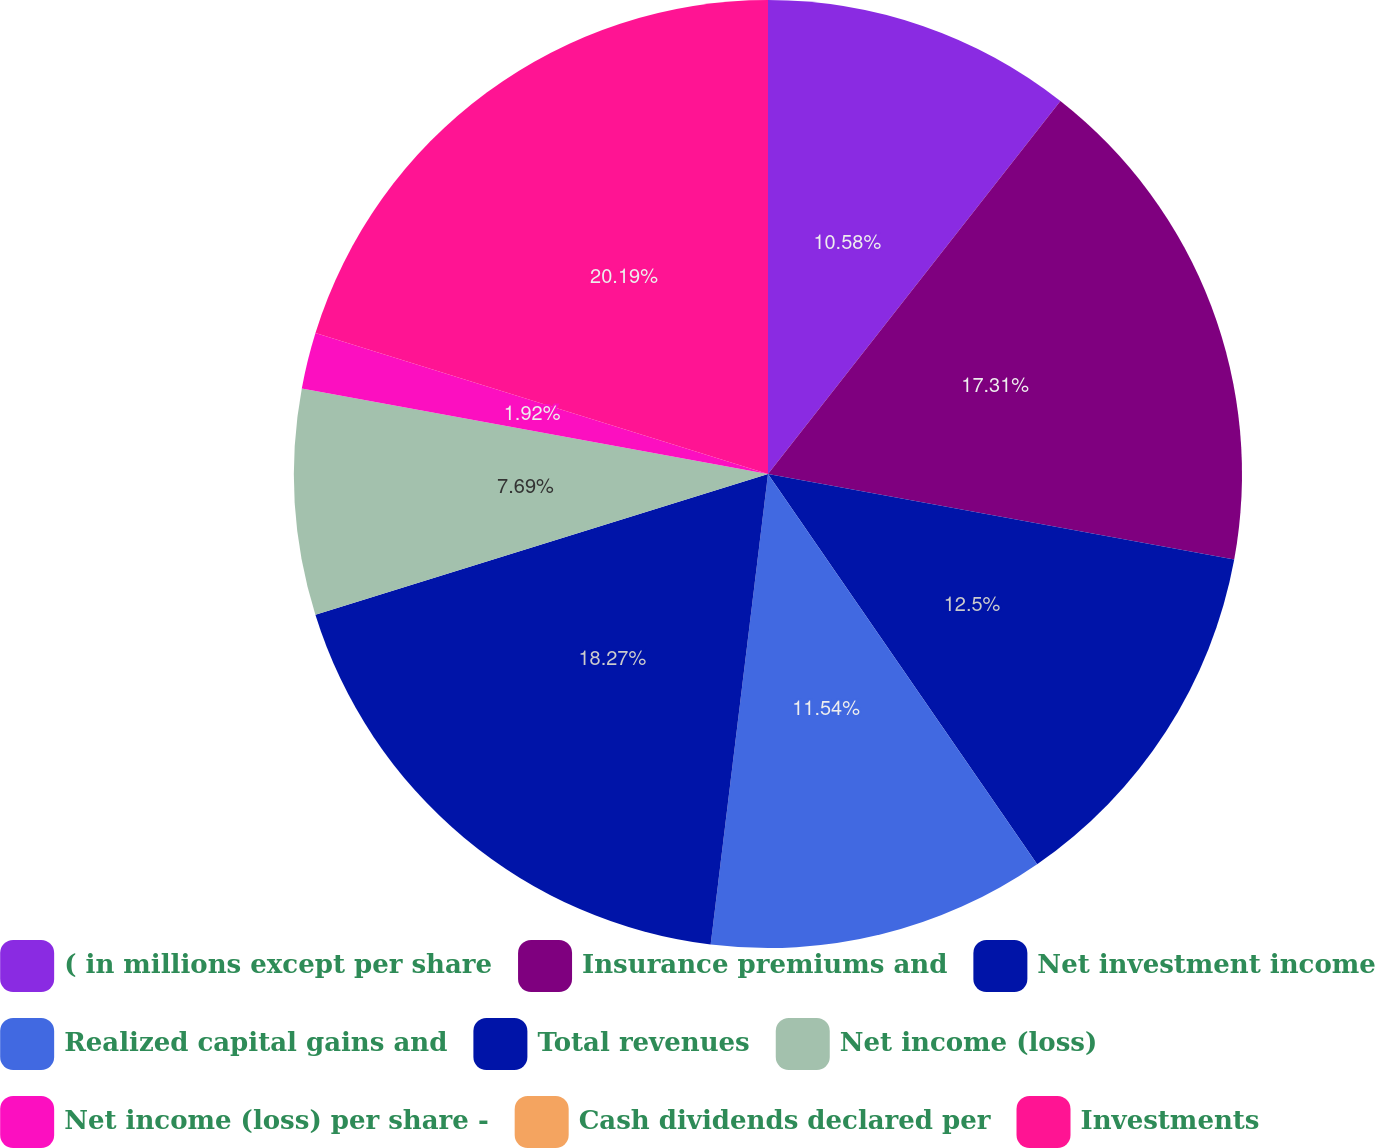Convert chart. <chart><loc_0><loc_0><loc_500><loc_500><pie_chart><fcel>( in millions except per share<fcel>Insurance premiums and<fcel>Net investment income<fcel>Realized capital gains and<fcel>Total revenues<fcel>Net income (loss)<fcel>Net income (loss) per share -<fcel>Cash dividends declared per<fcel>Investments<nl><fcel>10.58%<fcel>17.31%<fcel>12.5%<fcel>11.54%<fcel>18.27%<fcel>7.69%<fcel>1.92%<fcel>0.0%<fcel>20.19%<nl></chart> 